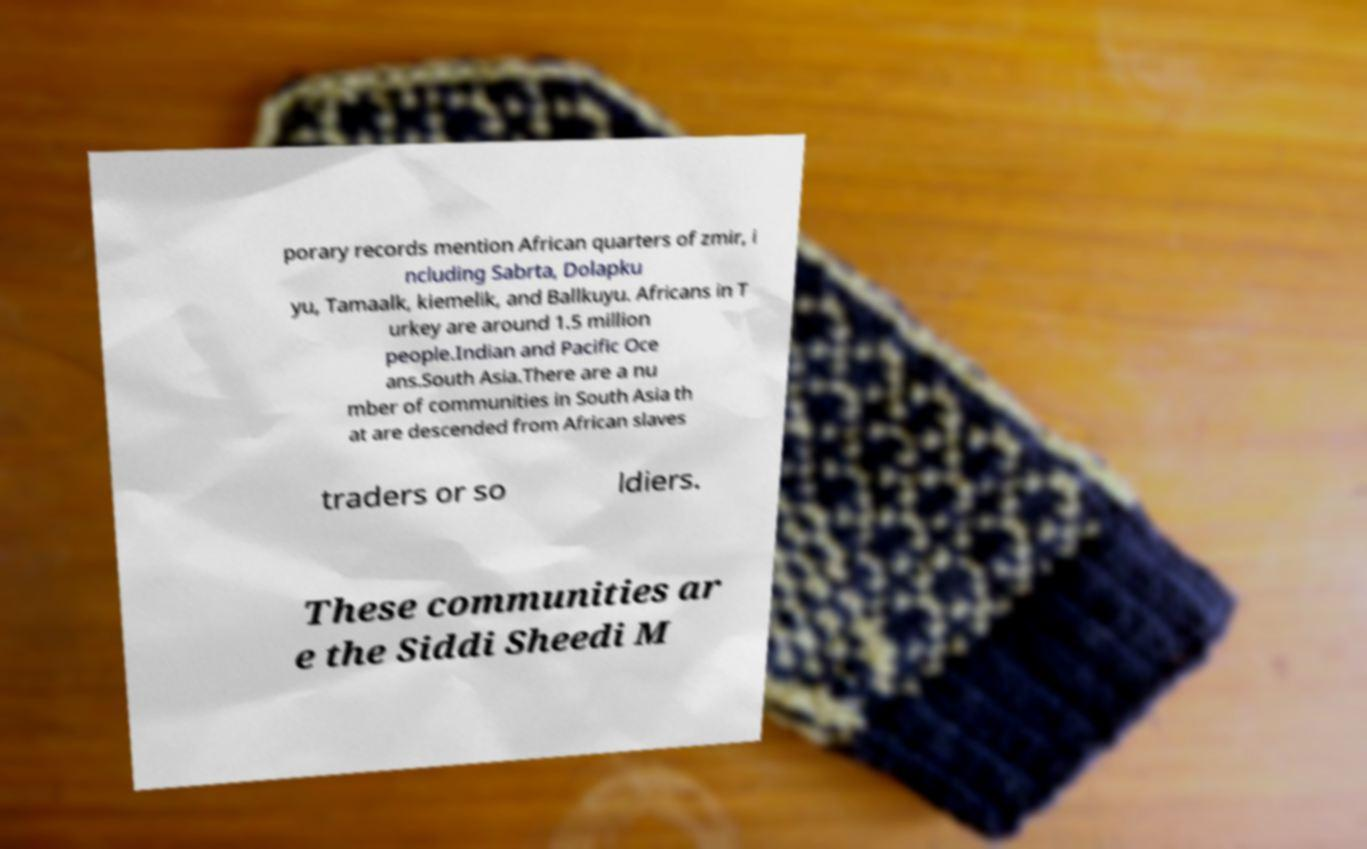Could you extract and type out the text from this image? porary records mention African quarters of zmir, i ncluding Sabrta, Dolapku yu, Tamaalk, kiemelik, and Ballkuyu. Africans in T urkey are around 1.5 million people.Indian and Pacific Oce ans.South Asia.There are a nu mber of communities in South Asia th at are descended from African slaves traders or so ldiers. These communities ar e the Siddi Sheedi M 